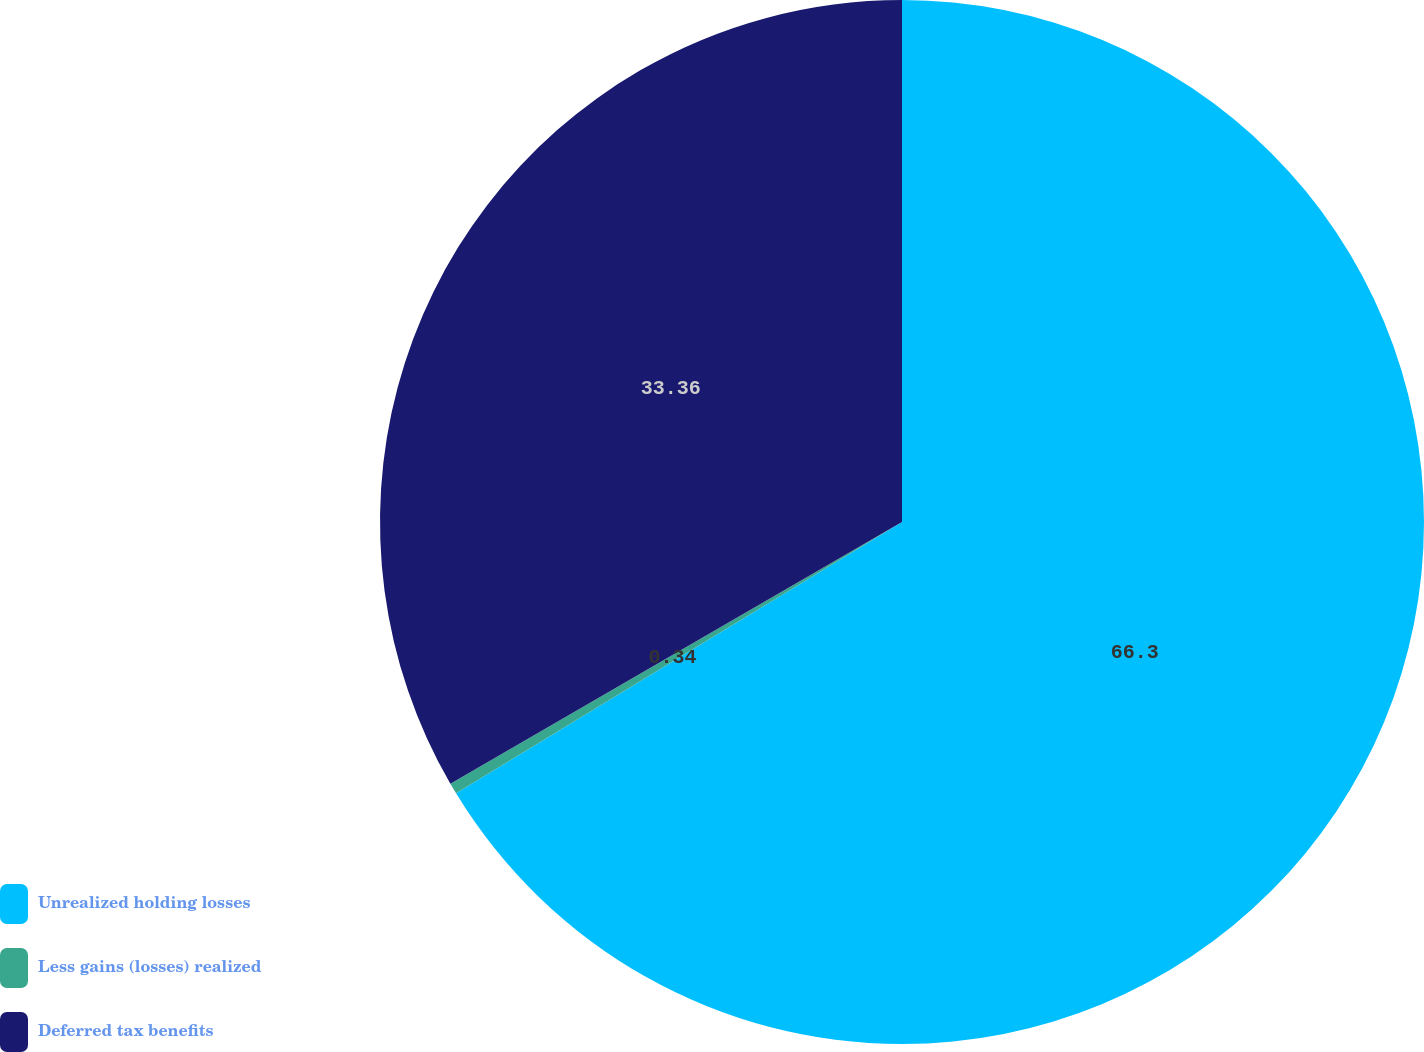<chart> <loc_0><loc_0><loc_500><loc_500><pie_chart><fcel>Unrealized holding losses<fcel>Less gains (losses) realized<fcel>Deferred tax benefits<nl><fcel>66.3%<fcel>0.34%<fcel>33.36%<nl></chart> 